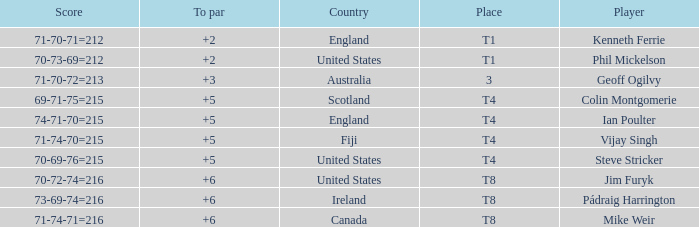What score to par did Mike Weir have? 6.0. 